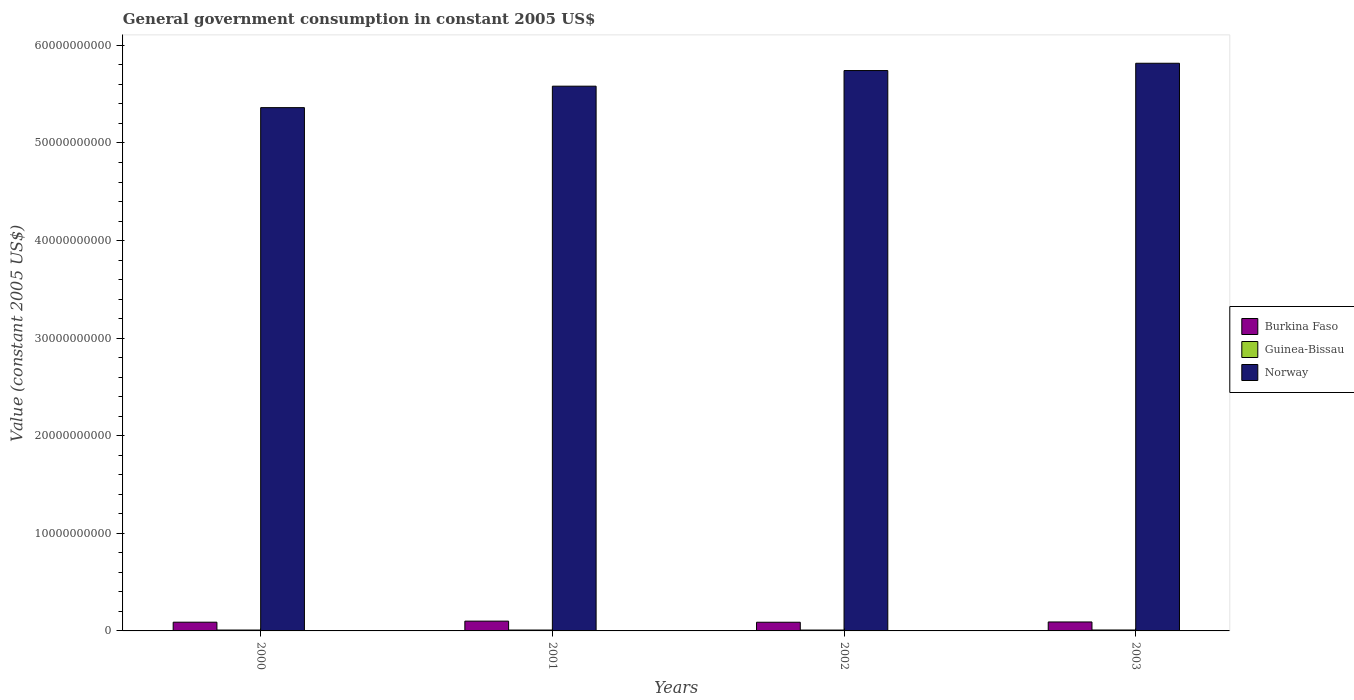How many different coloured bars are there?
Keep it short and to the point. 3. Are the number of bars per tick equal to the number of legend labels?
Offer a terse response. Yes. What is the government conusmption in Burkina Faso in 2001?
Ensure brevity in your answer.  1.00e+09. Across all years, what is the maximum government conusmption in Burkina Faso?
Your response must be concise. 1.00e+09. Across all years, what is the minimum government conusmption in Norway?
Ensure brevity in your answer.  5.36e+1. In which year was the government conusmption in Norway minimum?
Provide a short and direct response. 2000. What is the total government conusmption in Guinea-Bissau in the graph?
Your response must be concise. 3.65e+08. What is the difference between the government conusmption in Guinea-Bissau in 2001 and that in 2003?
Your answer should be very brief. -4.30e+06. What is the difference between the government conusmption in Norway in 2000 and the government conusmption in Burkina Faso in 2003?
Make the answer very short. 5.27e+1. What is the average government conusmption in Burkina Faso per year?
Provide a short and direct response. 9.26e+08. In the year 2000, what is the difference between the government conusmption in Burkina Faso and government conusmption in Guinea-Bissau?
Make the answer very short. 8.05e+08. What is the ratio of the government conusmption in Guinea-Bissau in 2000 to that in 2001?
Your answer should be compact. 0.99. What is the difference between the highest and the second highest government conusmption in Burkina Faso?
Your response must be concise. 8.57e+07. What is the difference between the highest and the lowest government conusmption in Norway?
Your answer should be compact. 4.55e+09. In how many years, is the government conusmption in Norway greater than the average government conusmption in Norway taken over all years?
Provide a short and direct response. 2. What does the 3rd bar from the left in 2003 represents?
Your answer should be compact. Norway. What does the 2nd bar from the right in 2001 represents?
Your answer should be very brief. Guinea-Bissau. Is it the case that in every year, the sum of the government conusmption in Burkina Faso and government conusmption in Norway is greater than the government conusmption in Guinea-Bissau?
Your answer should be compact. Yes. How many bars are there?
Your answer should be compact. 12. How many years are there in the graph?
Your answer should be very brief. 4. What is the difference between two consecutive major ticks on the Y-axis?
Your response must be concise. 1.00e+1. Does the graph contain any zero values?
Provide a succinct answer. No. Where does the legend appear in the graph?
Offer a very short reply. Center right. How many legend labels are there?
Make the answer very short. 3. How are the legend labels stacked?
Provide a succinct answer. Vertical. What is the title of the graph?
Make the answer very short. General government consumption in constant 2005 US$. Does "Zimbabwe" appear as one of the legend labels in the graph?
Your answer should be compact. No. What is the label or title of the Y-axis?
Your answer should be very brief. Value (constant 2005 US$). What is the Value (constant 2005 US$) of Burkina Faso in 2000?
Provide a short and direct response. 8.95e+08. What is the Value (constant 2005 US$) in Guinea-Bissau in 2000?
Make the answer very short. 9.01e+07. What is the Value (constant 2005 US$) in Norway in 2000?
Your answer should be compact. 5.36e+1. What is the Value (constant 2005 US$) in Burkina Faso in 2001?
Provide a succinct answer. 1.00e+09. What is the Value (constant 2005 US$) of Guinea-Bissau in 2001?
Ensure brevity in your answer.  9.12e+07. What is the Value (constant 2005 US$) in Norway in 2001?
Your answer should be compact. 5.58e+1. What is the Value (constant 2005 US$) of Burkina Faso in 2002?
Give a very brief answer. 8.90e+08. What is the Value (constant 2005 US$) of Guinea-Bissau in 2002?
Your response must be concise. 8.84e+07. What is the Value (constant 2005 US$) in Norway in 2002?
Your answer should be compact. 5.74e+1. What is the Value (constant 2005 US$) of Burkina Faso in 2003?
Offer a terse response. 9.18e+08. What is the Value (constant 2005 US$) in Guinea-Bissau in 2003?
Offer a terse response. 9.55e+07. What is the Value (constant 2005 US$) in Norway in 2003?
Make the answer very short. 5.82e+1. Across all years, what is the maximum Value (constant 2005 US$) of Burkina Faso?
Your answer should be very brief. 1.00e+09. Across all years, what is the maximum Value (constant 2005 US$) in Guinea-Bissau?
Ensure brevity in your answer.  9.55e+07. Across all years, what is the maximum Value (constant 2005 US$) of Norway?
Your answer should be compact. 5.82e+1. Across all years, what is the minimum Value (constant 2005 US$) of Burkina Faso?
Provide a short and direct response. 8.90e+08. Across all years, what is the minimum Value (constant 2005 US$) in Guinea-Bissau?
Provide a short and direct response. 8.84e+07. Across all years, what is the minimum Value (constant 2005 US$) in Norway?
Give a very brief answer. 5.36e+1. What is the total Value (constant 2005 US$) in Burkina Faso in the graph?
Provide a succinct answer. 3.71e+09. What is the total Value (constant 2005 US$) of Guinea-Bissau in the graph?
Provide a short and direct response. 3.65e+08. What is the total Value (constant 2005 US$) in Norway in the graph?
Keep it short and to the point. 2.25e+11. What is the difference between the Value (constant 2005 US$) of Burkina Faso in 2000 and that in 2001?
Offer a very short reply. -1.09e+08. What is the difference between the Value (constant 2005 US$) in Guinea-Bissau in 2000 and that in 2001?
Your answer should be compact. -1.06e+06. What is the difference between the Value (constant 2005 US$) of Norway in 2000 and that in 2001?
Ensure brevity in your answer.  -2.20e+09. What is the difference between the Value (constant 2005 US$) of Burkina Faso in 2000 and that in 2002?
Your answer should be compact. 4.82e+06. What is the difference between the Value (constant 2005 US$) in Guinea-Bissau in 2000 and that in 2002?
Provide a succinct answer. 1.71e+06. What is the difference between the Value (constant 2005 US$) of Norway in 2000 and that in 2002?
Offer a very short reply. -3.80e+09. What is the difference between the Value (constant 2005 US$) of Burkina Faso in 2000 and that in 2003?
Make the answer very short. -2.29e+07. What is the difference between the Value (constant 2005 US$) in Guinea-Bissau in 2000 and that in 2003?
Offer a terse response. -5.37e+06. What is the difference between the Value (constant 2005 US$) in Norway in 2000 and that in 2003?
Your answer should be very brief. -4.55e+09. What is the difference between the Value (constant 2005 US$) of Burkina Faso in 2001 and that in 2002?
Your response must be concise. 1.13e+08. What is the difference between the Value (constant 2005 US$) of Guinea-Bissau in 2001 and that in 2002?
Provide a short and direct response. 2.77e+06. What is the difference between the Value (constant 2005 US$) in Norway in 2001 and that in 2002?
Your answer should be compact. -1.60e+09. What is the difference between the Value (constant 2005 US$) in Burkina Faso in 2001 and that in 2003?
Offer a terse response. 8.57e+07. What is the difference between the Value (constant 2005 US$) in Guinea-Bissau in 2001 and that in 2003?
Your answer should be compact. -4.30e+06. What is the difference between the Value (constant 2005 US$) in Norway in 2001 and that in 2003?
Offer a terse response. -2.35e+09. What is the difference between the Value (constant 2005 US$) of Burkina Faso in 2002 and that in 2003?
Provide a short and direct response. -2.78e+07. What is the difference between the Value (constant 2005 US$) of Guinea-Bissau in 2002 and that in 2003?
Your answer should be compact. -7.07e+06. What is the difference between the Value (constant 2005 US$) of Norway in 2002 and that in 2003?
Your response must be concise. -7.47e+08. What is the difference between the Value (constant 2005 US$) in Burkina Faso in 2000 and the Value (constant 2005 US$) in Guinea-Bissau in 2001?
Your response must be concise. 8.03e+08. What is the difference between the Value (constant 2005 US$) in Burkina Faso in 2000 and the Value (constant 2005 US$) in Norway in 2001?
Provide a succinct answer. -5.49e+1. What is the difference between the Value (constant 2005 US$) in Guinea-Bissau in 2000 and the Value (constant 2005 US$) in Norway in 2001?
Offer a terse response. -5.57e+1. What is the difference between the Value (constant 2005 US$) of Burkina Faso in 2000 and the Value (constant 2005 US$) of Guinea-Bissau in 2002?
Your answer should be compact. 8.06e+08. What is the difference between the Value (constant 2005 US$) of Burkina Faso in 2000 and the Value (constant 2005 US$) of Norway in 2002?
Make the answer very short. -5.65e+1. What is the difference between the Value (constant 2005 US$) in Guinea-Bissau in 2000 and the Value (constant 2005 US$) in Norway in 2002?
Provide a succinct answer. -5.73e+1. What is the difference between the Value (constant 2005 US$) of Burkina Faso in 2000 and the Value (constant 2005 US$) of Guinea-Bissau in 2003?
Your answer should be very brief. 7.99e+08. What is the difference between the Value (constant 2005 US$) in Burkina Faso in 2000 and the Value (constant 2005 US$) in Norway in 2003?
Offer a very short reply. -5.73e+1. What is the difference between the Value (constant 2005 US$) of Guinea-Bissau in 2000 and the Value (constant 2005 US$) of Norway in 2003?
Your answer should be compact. -5.81e+1. What is the difference between the Value (constant 2005 US$) in Burkina Faso in 2001 and the Value (constant 2005 US$) in Guinea-Bissau in 2002?
Your answer should be very brief. 9.15e+08. What is the difference between the Value (constant 2005 US$) of Burkina Faso in 2001 and the Value (constant 2005 US$) of Norway in 2002?
Ensure brevity in your answer.  -5.64e+1. What is the difference between the Value (constant 2005 US$) in Guinea-Bissau in 2001 and the Value (constant 2005 US$) in Norway in 2002?
Offer a terse response. -5.73e+1. What is the difference between the Value (constant 2005 US$) of Burkina Faso in 2001 and the Value (constant 2005 US$) of Guinea-Bissau in 2003?
Provide a short and direct response. 9.08e+08. What is the difference between the Value (constant 2005 US$) in Burkina Faso in 2001 and the Value (constant 2005 US$) in Norway in 2003?
Keep it short and to the point. -5.72e+1. What is the difference between the Value (constant 2005 US$) in Guinea-Bissau in 2001 and the Value (constant 2005 US$) in Norway in 2003?
Your answer should be very brief. -5.81e+1. What is the difference between the Value (constant 2005 US$) in Burkina Faso in 2002 and the Value (constant 2005 US$) in Guinea-Bissau in 2003?
Your response must be concise. 7.94e+08. What is the difference between the Value (constant 2005 US$) of Burkina Faso in 2002 and the Value (constant 2005 US$) of Norway in 2003?
Ensure brevity in your answer.  -5.73e+1. What is the difference between the Value (constant 2005 US$) in Guinea-Bissau in 2002 and the Value (constant 2005 US$) in Norway in 2003?
Your answer should be compact. -5.81e+1. What is the average Value (constant 2005 US$) of Burkina Faso per year?
Ensure brevity in your answer.  9.26e+08. What is the average Value (constant 2005 US$) in Guinea-Bissau per year?
Provide a short and direct response. 9.13e+07. What is the average Value (constant 2005 US$) in Norway per year?
Offer a very short reply. 5.63e+1. In the year 2000, what is the difference between the Value (constant 2005 US$) in Burkina Faso and Value (constant 2005 US$) in Guinea-Bissau?
Offer a very short reply. 8.05e+08. In the year 2000, what is the difference between the Value (constant 2005 US$) in Burkina Faso and Value (constant 2005 US$) in Norway?
Give a very brief answer. -5.27e+1. In the year 2000, what is the difference between the Value (constant 2005 US$) in Guinea-Bissau and Value (constant 2005 US$) in Norway?
Give a very brief answer. -5.35e+1. In the year 2001, what is the difference between the Value (constant 2005 US$) of Burkina Faso and Value (constant 2005 US$) of Guinea-Bissau?
Your answer should be very brief. 9.12e+08. In the year 2001, what is the difference between the Value (constant 2005 US$) in Burkina Faso and Value (constant 2005 US$) in Norway?
Offer a very short reply. -5.48e+1. In the year 2001, what is the difference between the Value (constant 2005 US$) in Guinea-Bissau and Value (constant 2005 US$) in Norway?
Provide a short and direct response. -5.57e+1. In the year 2002, what is the difference between the Value (constant 2005 US$) of Burkina Faso and Value (constant 2005 US$) of Guinea-Bissau?
Your answer should be compact. 8.01e+08. In the year 2002, what is the difference between the Value (constant 2005 US$) in Burkina Faso and Value (constant 2005 US$) in Norway?
Provide a succinct answer. -5.65e+1. In the year 2002, what is the difference between the Value (constant 2005 US$) in Guinea-Bissau and Value (constant 2005 US$) in Norway?
Provide a short and direct response. -5.73e+1. In the year 2003, what is the difference between the Value (constant 2005 US$) in Burkina Faso and Value (constant 2005 US$) in Guinea-Bissau?
Your answer should be compact. 8.22e+08. In the year 2003, what is the difference between the Value (constant 2005 US$) of Burkina Faso and Value (constant 2005 US$) of Norway?
Make the answer very short. -5.73e+1. In the year 2003, what is the difference between the Value (constant 2005 US$) of Guinea-Bissau and Value (constant 2005 US$) of Norway?
Provide a succinct answer. -5.81e+1. What is the ratio of the Value (constant 2005 US$) of Burkina Faso in 2000 to that in 2001?
Offer a terse response. 0.89. What is the ratio of the Value (constant 2005 US$) of Guinea-Bissau in 2000 to that in 2001?
Provide a short and direct response. 0.99. What is the ratio of the Value (constant 2005 US$) of Norway in 2000 to that in 2001?
Make the answer very short. 0.96. What is the ratio of the Value (constant 2005 US$) in Burkina Faso in 2000 to that in 2002?
Make the answer very short. 1.01. What is the ratio of the Value (constant 2005 US$) in Guinea-Bissau in 2000 to that in 2002?
Your answer should be very brief. 1.02. What is the ratio of the Value (constant 2005 US$) of Norway in 2000 to that in 2002?
Give a very brief answer. 0.93. What is the ratio of the Value (constant 2005 US$) in Guinea-Bissau in 2000 to that in 2003?
Give a very brief answer. 0.94. What is the ratio of the Value (constant 2005 US$) of Norway in 2000 to that in 2003?
Offer a very short reply. 0.92. What is the ratio of the Value (constant 2005 US$) in Burkina Faso in 2001 to that in 2002?
Provide a succinct answer. 1.13. What is the ratio of the Value (constant 2005 US$) in Guinea-Bissau in 2001 to that in 2002?
Your answer should be compact. 1.03. What is the ratio of the Value (constant 2005 US$) of Norway in 2001 to that in 2002?
Give a very brief answer. 0.97. What is the ratio of the Value (constant 2005 US$) in Burkina Faso in 2001 to that in 2003?
Your answer should be very brief. 1.09. What is the ratio of the Value (constant 2005 US$) in Guinea-Bissau in 2001 to that in 2003?
Provide a short and direct response. 0.95. What is the ratio of the Value (constant 2005 US$) of Norway in 2001 to that in 2003?
Offer a terse response. 0.96. What is the ratio of the Value (constant 2005 US$) in Burkina Faso in 2002 to that in 2003?
Your response must be concise. 0.97. What is the ratio of the Value (constant 2005 US$) of Guinea-Bissau in 2002 to that in 2003?
Make the answer very short. 0.93. What is the ratio of the Value (constant 2005 US$) in Norway in 2002 to that in 2003?
Your answer should be very brief. 0.99. What is the difference between the highest and the second highest Value (constant 2005 US$) in Burkina Faso?
Provide a short and direct response. 8.57e+07. What is the difference between the highest and the second highest Value (constant 2005 US$) in Guinea-Bissau?
Give a very brief answer. 4.30e+06. What is the difference between the highest and the second highest Value (constant 2005 US$) of Norway?
Make the answer very short. 7.47e+08. What is the difference between the highest and the lowest Value (constant 2005 US$) of Burkina Faso?
Ensure brevity in your answer.  1.13e+08. What is the difference between the highest and the lowest Value (constant 2005 US$) in Guinea-Bissau?
Keep it short and to the point. 7.07e+06. What is the difference between the highest and the lowest Value (constant 2005 US$) of Norway?
Give a very brief answer. 4.55e+09. 